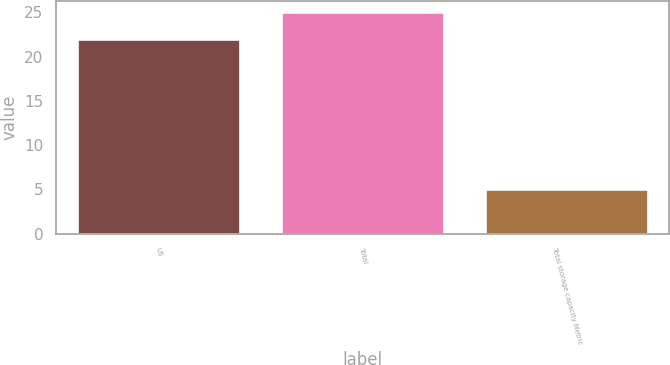Convert chart to OTSL. <chart><loc_0><loc_0><loc_500><loc_500><bar_chart><fcel>US<fcel>Total<fcel>Total storage capacity Metric<nl><fcel>22<fcel>25<fcel>5<nl></chart> 